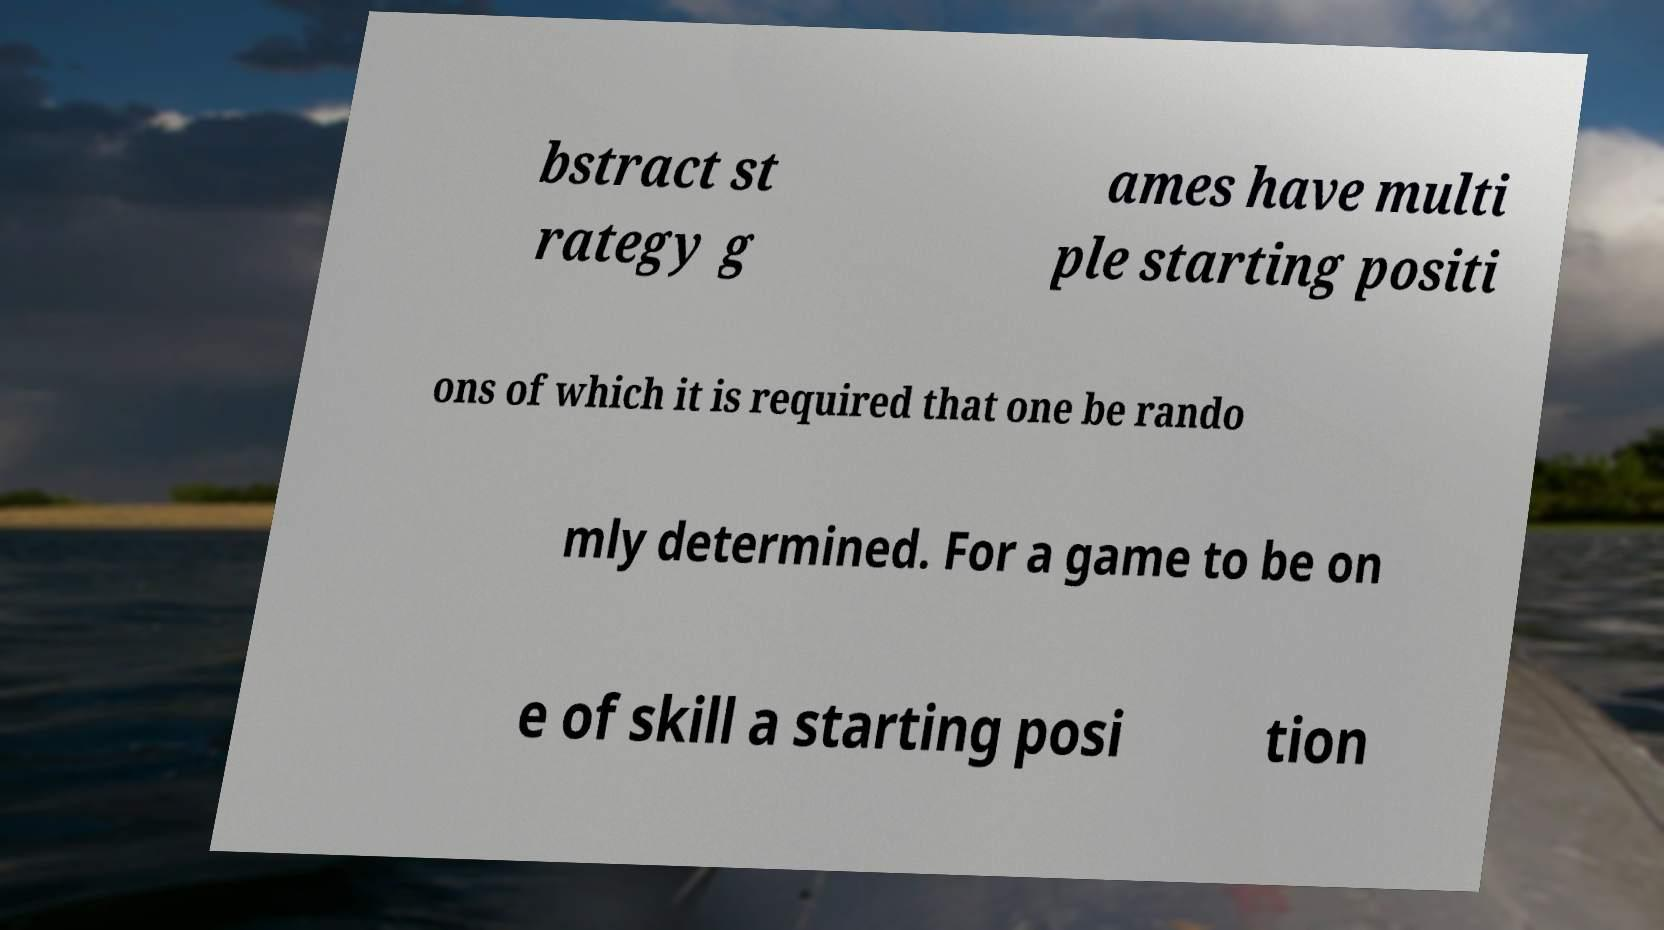Can you accurately transcribe the text from the provided image for me? bstract st rategy g ames have multi ple starting positi ons of which it is required that one be rando mly determined. For a game to be on e of skill a starting posi tion 